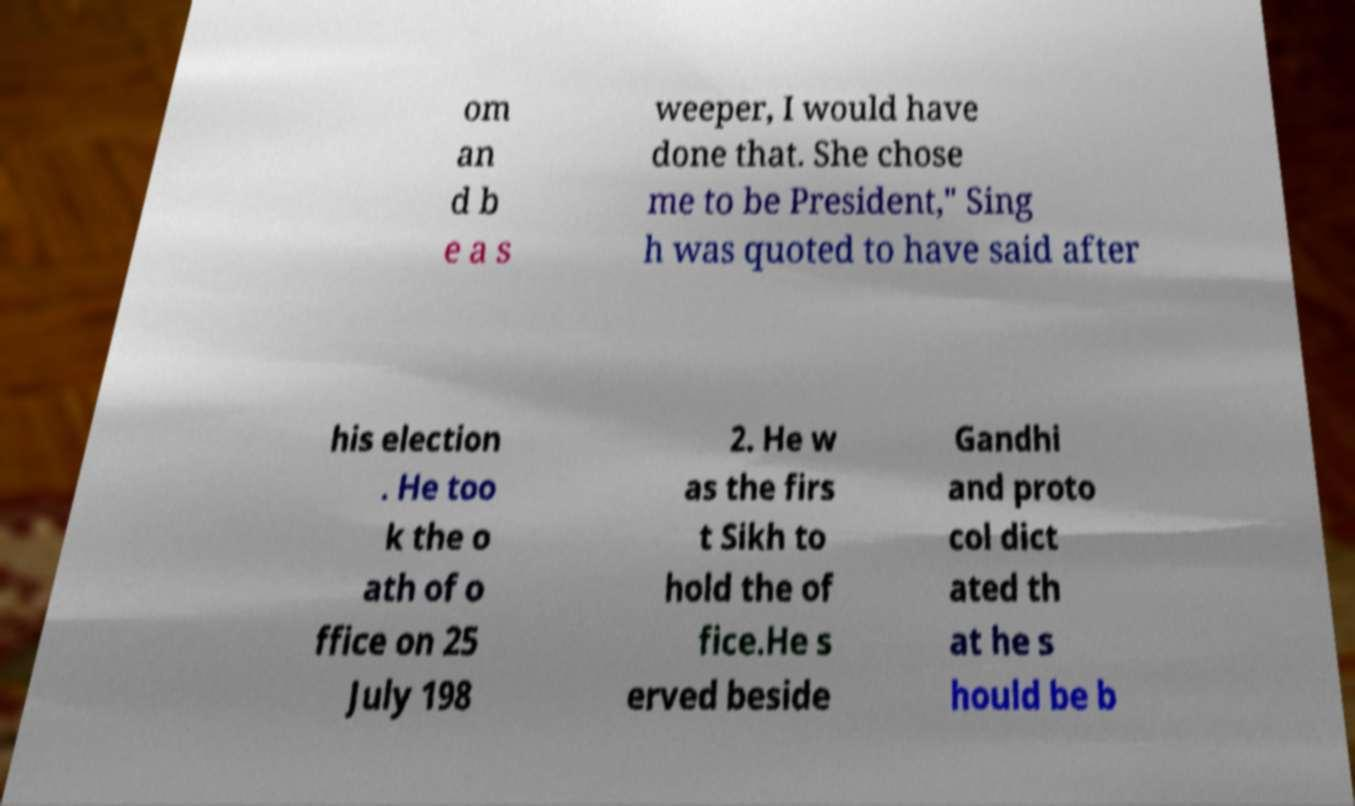What messages or text are displayed in this image? I need them in a readable, typed format. om an d b e a s weeper, I would have done that. She chose me to be President," Sing h was quoted to have said after his election . He too k the o ath of o ffice on 25 July 198 2. He w as the firs t Sikh to hold the of fice.He s erved beside Gandhi and proto col dict ated th at he s hould be b 